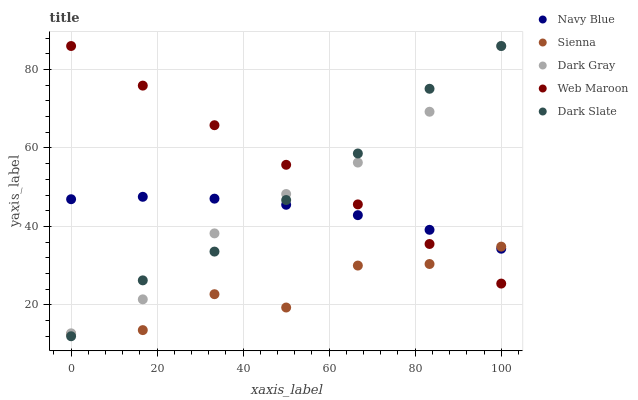Does Sienna have the minimum area under the curve?
Answer yes or no. Yes. Does Web Maroon have the maximum area under the curve?
Answer yes or no. Yes. Does Navy Blue have the minimum area under the curve?
Answer yes or no. No. Does Navy Blue have the maximum area under the curve?
Answer yes or no. No. Is Web Maroon the smoothest?
Answer yes or no. Yes. Is Sienna the roughest?
Answer yes or no. Yes. Is Navy Blue the smoothest?
Answer yes or no. No. Is Navy Blue the roughest?
Answer yes or no. No. Does Dark Slate have the lowest value?
Answer yes or no. Yes. Does Dark Gray have the lowest value?
Answer yes or no. No. Does Dark Slate have the highest value?
Answer yes or no. Yes. Does Navy Blue have the highest value?
Answer yes or no. No. Is Sienna less than Dark Gray?
Answer yes or no. Yes. Is Dark Gray greater than Sienna?
Answer yes or no. Yes. Does Dark Gray intersect Web Maroon?
Answer yes or no. Yes. Is Dark Gray less than Web Maroon?
Answer yes or no. No. Is Dark Gray greater than Web Maroon?
Answer yes or no. No. Does Sienna intersect Dark Gray?
Answer yes or no. No. 